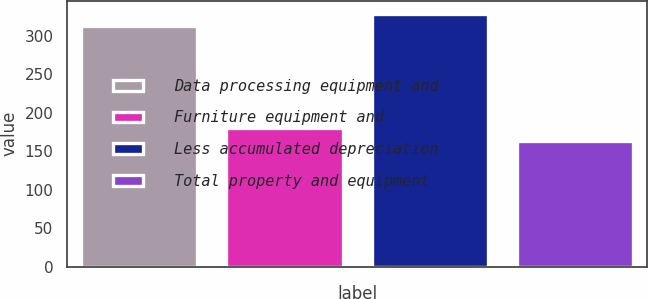<chart> <loc_0><loc_0><loc_500><loc_500><bar_chart><fcel>Data processing equipment and<fcel>Furniture equipment and<fcel>Less accumulated depreciation<fcel>Total property and equipment<nl><fcel>313<fcel>180.3<fcel>329.3<fcel>164<nl></chart> 